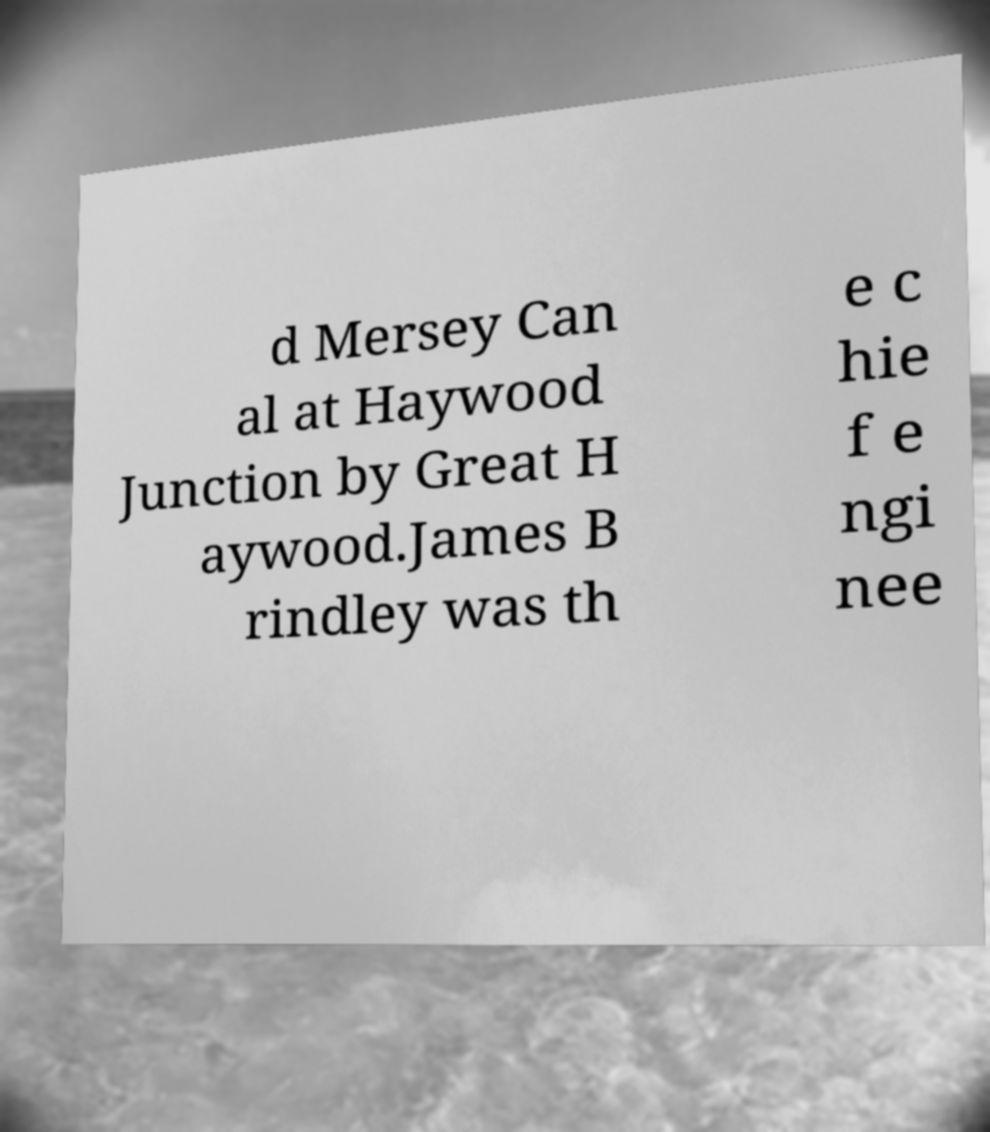Could you extract and type out the text from this image? d Mersey Can al at Haywood Junction by Great H aywood.James B rindley was th e c hie f e ngi nee 